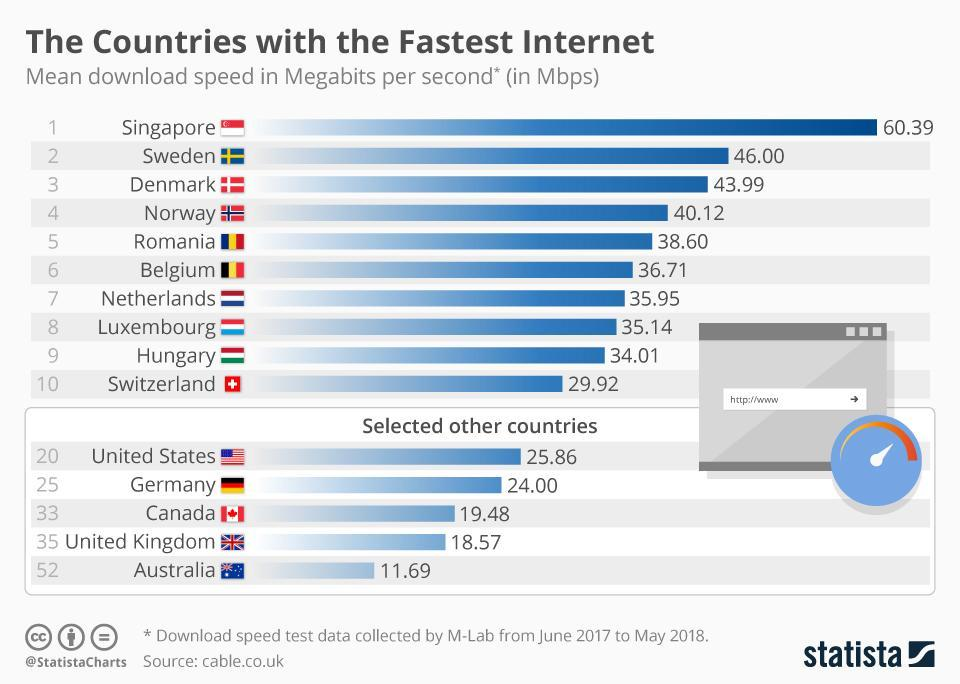Which country has third highest download speed among selected other countries?
Answer the question with a short phrase. Canada What duration was the test done? June 2017 to May 2018 Which country has second highest internet speed among first ten countries? Sweden How many countries have mean download speed above 40.00 Mbps? 4 